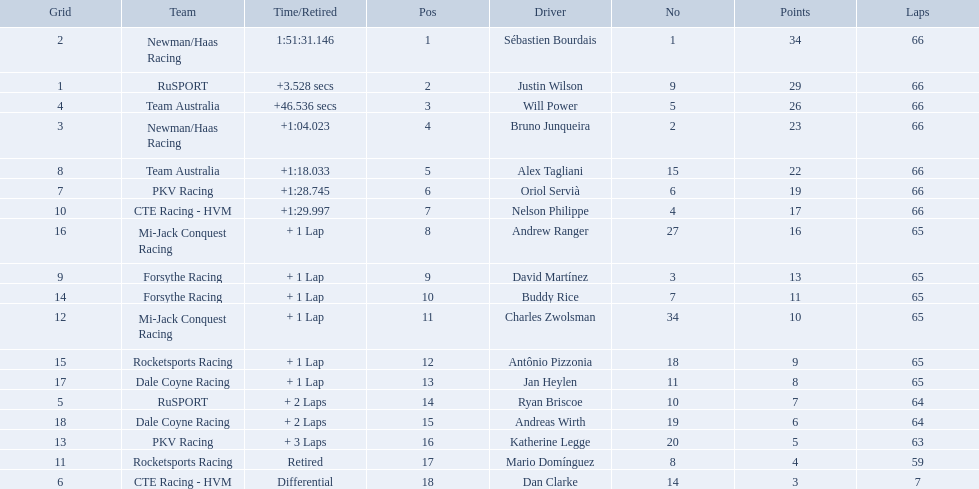Which teams participated in the 2006 gran premio telmex? Newman/Haas Racing, RuSPORT, Team Australia, Newman/Haas Racing, Team Australia, PKV Racing, CTE Racing - HVM, Mi-Jack Conquest Racing, Forsythe Racing, Forsythe Racing, Mi-Jack Conquest Racing, Rocketsports Racing, Dale Coyne Racing, RuSPORT, Dale Coyne Racing, PKV Racing, Rocketsports Racing, CTE Racing - HVM. Who were the drivers of these teams? Sébastien Bourdais, Justin Wilson, Will Power, Bruno Junqueira, Alex Tagliani, Oriol Servià, Nelson Philippe, Andrew Ranger, David Martínez, Buddy Rice, Charles Zwolsman, Antônio Pizzonia, Jan Heylen, Ryan Briscoe, Andreas Wirth, Katherine Legge, Mario Domínguez, Dan Clarke. Which driver finished last? Dan Clarke. 